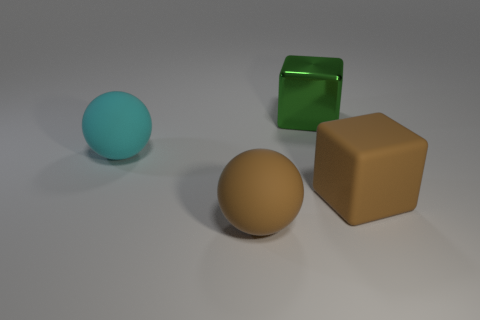What color is the large object that is both behind the big brown rubber ball and on the left side of the green shiny cube?
Keep it short and to the point. Cyan. There is a green thing right of the brown thing that is left of the big metal object; what is it made of?
Ensure brevity in your answer.  Metal. What size is the other thing that is the same shape as the cyan object?
Give a very brief answer. Large. Is the color of the ball that is to the right of the cyan matte object the same as the big rubber block?
Provide a succinct answer. Yes. Is the number of big cyan balls less than the number of cyan cylinders?
Make the answer very short. No. How many other objects are there of the same color as the metal cube?
Your response must be concise. 0. Do the large cyan object behind the large brown rubber block and the brown block have the same material?
Keep it short and to the point. Yes. What is the green block behind the brown cube made of?
Your answer should be very brief. Metal. How big is the brown thing in front of the brown rubber thing behind the brown sphere?
Offer a terse response. Large. Are there any tiny purple cylinders that have the same material as the large brown sphere?
Provide a short and direct response. No. 